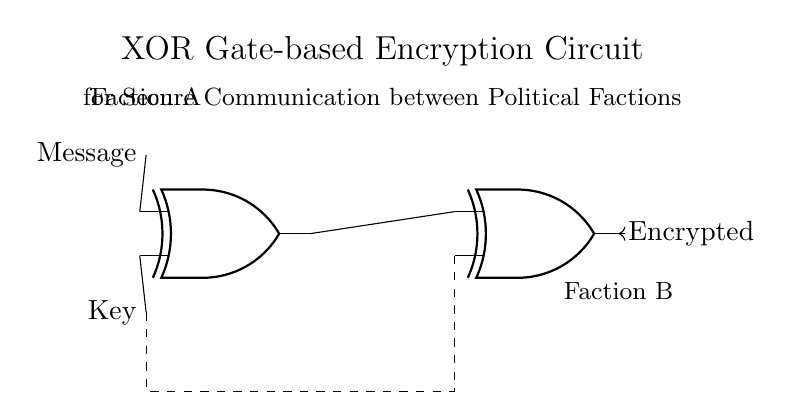What are the two types of gates used in this circuit? The circuit uses XOR gates, specifically two of them, indicated by the nodes labelled as "XOR1" and "XOR2".
Answer: XOR gates What is the purpose of the dashed lines in the diagram? The dashed lines represent key distribution from one component to another, signifying the transfer of the encryption key to the second XOR gate for combining with the encrypted message.
Answer: Key distribution How many inputs does each XOR gate have? Each XOR gate has two inputs, with one receiving the message and the other receiving the key in the first gate, and the second XOR gate receiving the output from the first gate as one input and the key as the second.
Answer: Two inputs Which factions are represented in the communication circuit? The circuit labels two factions, as described by "Faction A" for the message initiator and "Faction B" for the recipient of the encrypted message, located on opposite sides of the diagram.
Answer: Faction A and Faction B What is the output of the second XOR gate? The output of the second XOR gate is the final encrypted message. The connection from "XOR2.out" to the right side indicates that the processed information is sent out in encrypted form.
Answer: Encrypted message Why is an XOR gate suitable for encryption? An XOR gate is suitable for encryption because it outputs true (or follows a defined positive signal) only when the number of true inputs is odd, making it effective for creating a secure ciphertext when combining message data with a key, providing data obfuscation.
Answer: Data obfuscation 